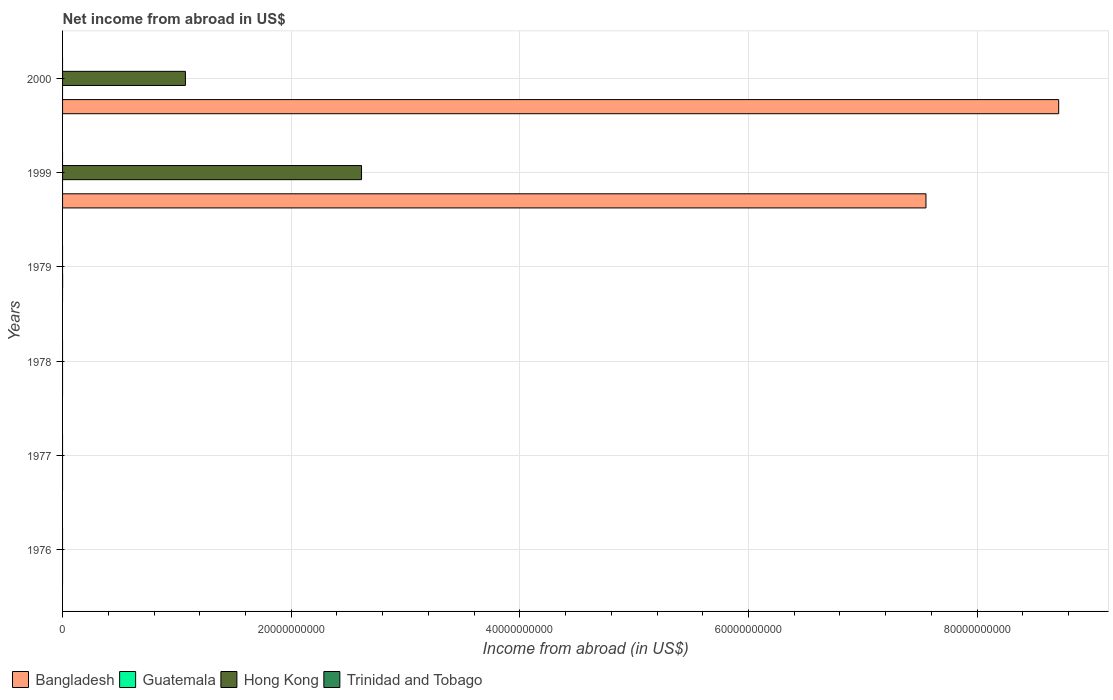Are the number of bars on each tick of the Y-axis equal?
Your response must be concise. No. What is the label of the 2nd group of bars from the top?
Ensure brevity in your answer.  1999. Across all years, what is the maximum net income from abroad in Bangladesh?
Your answer should be very brief. 8.71e+1. Across all years, what is the minimum net income from abroad in Trinidad and Tobago?
Make the answer very short. 0. In which year was the net income from abroad in Guatemala maximum?
Ensure brevity in your answer.  1979. What is the total net income from abroad in Bangladesh in the graph?
Keep it short and to the point. 1.63e+11. What is the average net income from abroad in Guatemala per year?
Ensure brevity in your answer.  4.33e+05. What is the difference between the highest and the lowest net income from abroad in Bangladesh?
Offer a very short reply. 8.71e+1. In how many years, is the net income from abroad in Trinidad and Tobago greater than the average net income from abroad in Trinidad and Tobago taken over all years?
Your response must be concise. 0. Is it the case that in every year, the sum of the net income from abroad in Hong Kong and net income from abroad in Trinidad and Tobago is greater than the sum of net income from abroad in Bangladesh and net income from abroad in Guatemala?
Ensure brevity in your answer.  No. How are the legend labels stacked?
Your answer should be very brief. Horizontal. What is the title of the graph?
Your answer should be compact. Net income from abroad in US$. Does "Jamaica" appear as one of the legend labels in the graph?
Provide a short and direct response. No. What is the label or title of the X-axis?
Make the answer very short. Income from abroad (in US$). What is the Income from abroad (in US$) of Hong Kong in 1976?
Provide a succinct answer. 0. What is the Income from abroad (in US$) of Trinidad and Tobago in 1976?
Your answer should be very brief. 0. What is the Income from abroad (in US$) in Guatemala in 1977?
Your response must be concise. 0. What is the Income from abroad (in US$) in Trinidad and Tobago in 1977?
Your response must be concise. 0. What is the Income from abroad (in US$) in Bangladesh in 1978?
Make the answer very short. 0. What is the Income from abroad (in US$) of Guatemala in 1978?
Your response must be concise. 0. What is the Income from abroad (in US$) of Hong Kong in 1978?
Ensure brevity in your answer.  0. What is the Income from abroad (in US$) in Bangladesh in 1979?
Offer a terse response. 0. What is the Income from abroad (in US$) of Guatemala in 1979?
Offer a terse response. 2.60e+06. What is the Income from abroad (in US$) of Hong Kong in 1979?
Make the answer very short. 0. What is the Income from abroad (in US$) in Bangladesh in 1999?
Offer a terse response. 7.55e+1. What is the Income from abroad (in US$) in Guatemala in 1999?
Keep it short and to the point. 0. What is the Income from abroad (in US$) of Hong Kong in 1999?
Provide a succinct answer. 2.62e+1. What is the Income from abroad (in US$) in Trinidad and Tobago in 1999?
Provide a succinct answer. 0. What is the Income from abroad (in US$) in Bangladesh in 2000?
Provide a short and direct response. 8.71e+1. What is the Income from abroad (in US$) in Hong Kong in 2000?
Keep it short and to the point. 1.07e+1. Across all years, what is the maximum Income from abroad (in US$) of Bangladesh?
Your response must be concise. 8.71e+1. Across all years, what is the maximum Income from abroad (in US$) in Guatemala?
Ensure brevity in your answer.  2.60e+06. Across all years, what is the maximum Income from abroad (in US$) of Hong Kong?
Your answer should be very brief. 2.62e+1. Across all years, what is the minimum Income from abroad (in US$) in Guatemala?
Your response must be concise. 0. What is the total Income from abroad (in US$) of Bangladesh in the graph?
Give a very brief answer. 1.63e+11. What is the total Income from abroad (in US$) of Guatemala in the graph?
Your answer should be very brief. 2.60e+06. What is the total Income from abroad (in US$) in Hong Kong in the graph?
Make the answer very short. 3.69e+1. What is the total Income from abroad (in US$) of Trinidad and Tobago in the graph?
Your answer should be compact. 0. What is the difference between the Income from abroad (in US$) in Bangladesh in 1999 and that in 2000?
Give a very brief answer. -1.16e+1. What is the difference between the Income from abroad (in US$) of Hong Kong in 1999 and that in 2000?
Ensure brevity in your answer.  1.54e+1. What is the difference between the Income from abroad (in US$) in Guatemala in 1979 and the Income from abroad (in US$) in Hong Kong in 1999?
Your response must be concise. -2.61e+1. What is the difference between the Income from abroad (in US$) of Guatemala in 1979 and the Income from abroad (in US$) of Hong Kong in 2000?
Make the answer very short. -1.07e+1. What is the difference between the Income from abroad (in US$) of Bangladesh in 1999 and the Income from abroad (in US$) of Hong Kong in 2000?
Offer a very short reply. 6.48e+1. What is the average Income from abroad (in US$) of Bangladesh per year?
Your answer should be very brief. 2.71e+1. What is the average Income from abroad (in US$) in Guatemala per year?
Offer a terse response. 4.33e+05. What is the average Income from abroad (in US$) of Hong Kong per year?
Offer a terse response. 6.15e+09. In the year 1999, what is the difference between the Income from abroad (in US$) in Bangladesh and Income from abroad (in US$) in Hong Kong?
Your answer should be compact. 4.94e+1. In the year 2000, what is the difference between the Income from abroad (in US$) of Bangladesh and Income from abroad (in US$) of Hong Kong?
Your answer should be very brief. 7.64e+1. What is the ratio of the Income from abroad (in US$) of Bangladesh in 1999 to that in 2000?
Give a very brief answer. 0.87. What is the ratio of the Income from abroad (in US$) of Hong Kong in 1999 to that in 2000?
Keep it short and to the point. 2.43. What is the difference between the highest and the lowest Income from abroad (in US$) in Bangladesh?
Ensure brevity in your answer.  8.71e+1. What is the difference between the highest and the lowest Income from abroad (in US$) of Guatemala?
Ensure brevity in your answer.  2.60e+06. What is the difference between the highest and the lowest Income from abroad (in US$) of Hong Kong?
Your answer should be very brief. 2.62e+1. 